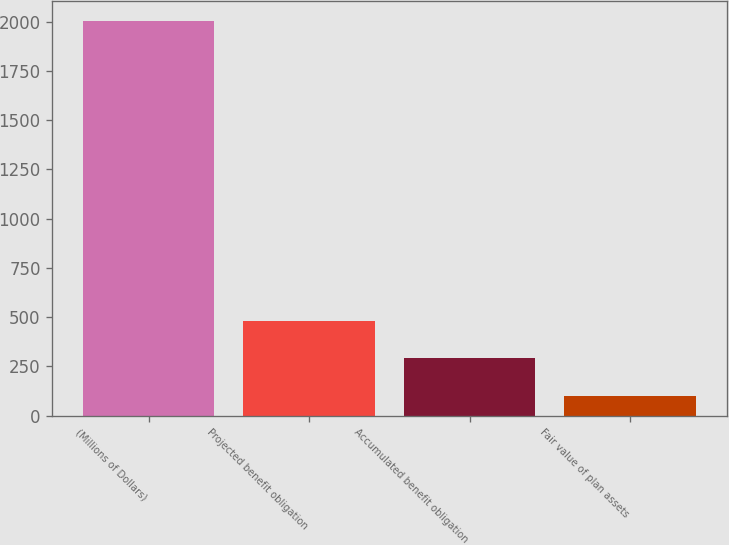Convert chart to OTSL. <chart><loc_0><loc_0><loc_500><loc_500><bar_chart><fcel>(Millions of Dollars)<fcel>Projected benefit obligation<fcel>Accumulated benefit obligation<fcel>Fair value of plan assets<nl><fcel>2005<fcel>482.44<fcel>292.12<fcel>101.8<nl></chart> 